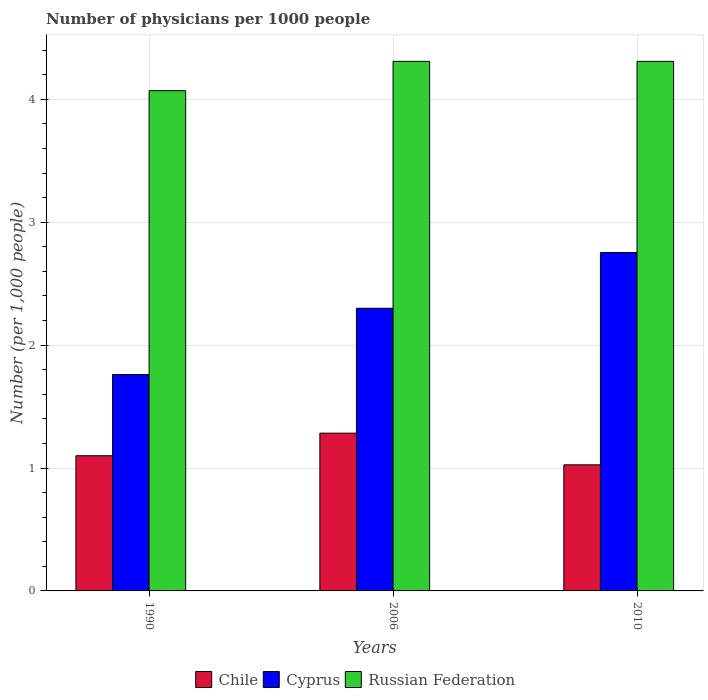How many groups of bars are there?
Your answer should be compact. 3. How many bars are there on the 2nd tick from the right?
Make the answer very short. 3. What is the number of physicians in Chile in 2006?
Make the answer very short. 1.28. Across all years, what is the maximum number of physicians in Chile?
Your response must be concise. 1.28. Across all years, what is the minimum number of physicians in Russian Federation?
Your answer should be compact. 4.07. In which year was the number of physicians in Cyprus maximum?
Provide a short and direct response. 2010. In which year was the number of physicians in Cyprus minimum?
Provide a succinct answer. 1990. What is the total number of physicians in Cyprus in the graph?
Ensure brevity in your answer.  6.81. What is the difference between the number of physicians in Chile in 2006 and that in 2010?
Offer a terse response. 0.26. What is the difference between the number of physicians in Chile in 2010 and the number of physicians in Cyprus in 2006?
Keep it short and to the point. -1.27. What is the average number of physicians in Russian Federation per year?
Provide a succinct answer. 4.23. In the year 2010, what is the difference between the number of physicians in Russian Federation and number of physicians in Cyprus?
Provide a short and direct response. 1.56. What is the ratio of the number of physicians in Cyprus in 1990 to that in 2006?
Keep it short and to the point. 0.77. Is the number of physicians in Chile in 1990 less than that in 2006?
Your response must be concise. Yes. What is the difference between the highest and the second highest number of physicians in Russian Federation?
Your answer should be very brief. 9.999999999976694e-5. What is the difference between the highest and the lowest number of physicians in Chile?
Provide a succinct answer. 0.26. What does the 2nd bar from the right in 2006 represents?
Provide a succinct answer. Cyprus. What is the difference between two consecutive major ticks on the Y-axis?
Your answer should be compact. 1. Does the graph contain grids?
Keep it short and to the point. Yes. What is the title of the graph?
Make the answer very short. Number of physicians per 1000 people. Does "United Kingdom" appear as one of the legend labels in the graph?
Give a very brief answer. No. What is the label or title of the X-axis?
Your answer should be compact. Years. What is the label or title of the Y-axis?
Keep it short and to the point. Number (per 1,0 people). What is the Number (per 1,000 people) of Chile in 1990?
Provide a short and direct response. 1.1. What is the Number (per 1,000 people) in Cyprus in 1990?
Your response must be concise. 1.76. What is the Number (per 1,000 people) in Russian Federation in 1990?
Make the answer very short. 4.07. What is the Number (per 1,000 people) of Chile in 2006?
Provide a succinct answer. 1.28. What is the Number (per 1,000 people) in Cyprus in 2006?
Your response must be concise. 2.3. What is the Number (per 1,000 people) in Russian Federation in 2006?
Your answer should be compact. 4.31. What is the Number (per 1,000 people) of Chile in 2010?
Offer a very short reply. 1.03. What is the Number (per 1,000 people) of Cyprus in 2010?
Make the answer very short. 2.75. What is the Number (per 1,000 people) of Russian Federation in 2010?
Provide a short and direct response. 4.31. Across all years, what is the maximum Number (per 1,000 people) of Chile?
Your answer should be very brief. 1.28. Across all years, what is the maximum Number (per 1,000 people) in Cyprus?
Your answer should be very brief. 2.75. Across all years, what is the maximum Number (per 1,000 people) of Russian Federation?
Provide a short and direct response. 4.31. Across all years, what is the minimum Number (per 1,000 people) in Cyprus?
Keep it short and to the point. 1.76. Across all years, what is the minimum Number (per 1,000 people) in Russian Federation?
Keep it short and to the point. 4.07. What is the total Number (per 1,000 people) of Chile in the graph?
Offer a terse response. 3.41. What is the total Number (per 1,000 people) in Cyprus in the graph?
Provide a succinct answer. 6.81. What is the total Number (per 1,000 people) of Russian Federation in the graph?
Your answer should be compact. 12.69. What is the difference between the Number (per 1,000 people) of Chile in 1990 and that in 2006?
Your answer should be very brief. -0.18. What is the difference between the Number (per 1,000 people) of Cyprus in 1990 and that in 2006?
Offer a terse response. -0.54. What is the difference between the Number (per 1,000 people) in Russian Federation in 1990 and that in 2006?
Keep it short and to the point. -0.24. What is the difference between the Number (per 1,000 people) of Chile in 1990 and that in 2010?
Offer a very short reply. 0.07. What is the difference between the Number (per 1,000 people) in Cyprus in 1990 and that in 2010?
Your answer should be very brief. -0.99. What is the difference between the Number (per 1,000 people) of Russian Federation in 1990 and that in 2010?
Provide a short and direct response. -0.24. What is the difference between the Number (per 1,000 people) of Chile in 2006 and that in 2010?
Keep it short and to the point. 0.26. What is the difference between the Number (per 1,000 people) of Cyprus in 2006 and that in 2010?
Offer a terse response. -0.45. What is the difference between the Number (per 1,000 people) in Chile in 1990 and the Number (per 1,000 people) in Cyprus in 2006?
Provide a short and direct response. -1.2. What is the difference between the Number (per 1,000 people) of Chile in 1990 and the Number (per 1,000 people) of Russian Federation in 2006?
Provide a succinct answer. -3.21. What is the difference between the Number (per 1,000 people) of Cyprus in 1990 and the Number (per 1,000 people) of Russian Federation in 2006?
Your answer should be compact. -2.55. What is the difference between the Number (per 1,000 people) of Chile in 1990 and the Number (per 1,000 people) of Cyprus in 2010?
Keep it short and to the point. -1.65. What is the difference between the Number (per 1,000 people) of Chile in 1990 and the Number (per 1,000 people) of Russian Federation in 2010?
Provide a succinct answer. -3.21. What is the difference between the Number (per 1,000 people) in Cyprus in 1990 and the Number (per 1,000 people) in Russian Federation in 2010?
Provide a short and direct response. -2.55. What is the difference between the Number (per 1,000 people) of Chile in 2006 and the Number (per 1,000 people) of Cyprus in 2010?
Ensure brevity in your answer.  -1.47. What is the difference between the Number (per 1,000 people) of Chile in 2006 and the Number (per 1,000 people) of Russian Federation in 2010?
Your response must be concise. -3.03. What is the difference between the Number (per 1,000 people) in Cyprus in 2006 and the Number (per 1,000 people) in Russian Federation in 2010?
Provide a short and direct response. -2.01. What is the average Number (per 1,000 people) in Chile per year?
Give a very brief answer. 1.14. What is the average Number (per 1,000 people) of Cyprus per year?
Keep it short and to the point. 2.27. What is the average Number (per 1,000 people) in Russian Federation per year?
Make the answer very short. 4.23. In the year 1990, what is the difference between the Number (per 1,000 people) in Chile and Number (per 1,000 people) in Cyprus?
Give a very brief answer. -0.66. In the year 1990, what is the difference between the Number (per 1,000 people) in Chile and Number (per 1,000 people) in Russian Federation?
Offer a very short reply. -2.97. In the year 1990, what is the difference between the Number (per 1,000 people) of Cyprus and Number (per 1,000 people) of Russian Federation?
Give a very brief answer. -2.31. In the year 2006, what is the difference between the Number (per 1,000 people) of Chile and Number (per 1,000 people) of Cyprus?
Provide a short and direct response. -1.02. In the year 2006, what is the difference between the Number (per 1,000 people) in Chile and Number (per 1,000 people) in Russian Federation?
Your answer should be very brief. -3.03. In the year 2006, what is the difference between the Number (per 1,000 people) of Cyprus and Number (per 1,000 people) of Russian Federation?
Give a very brief answer. -2.01. In the year 2010, what is the difference between the Number (per 1,000 people) of Chile and Number (per 1,000 people) of Cyprus?
Your answer should be very brief. -1.73. In the year 2010, what is the difference between the Number (per 1,000 people) of Chile and Number (per 1,000 people) of Russian Federation?
Provide a succinct answer. -3.28. In the year 2010, what is the difference between the Number (per 1,000 people) of Cyprus and Number (per 1,000 people) of Russian Federation?
Your answer should be very brief. -1.56. What is the ratio of the Number (per 1,000 people) in Chile in 1990 to that in 2006?
Provide a short and direct response. 0.86. What is the ratio of the Number (per 1,000 people) in Cyprus in 1990 to that in 2006?
Keep it short and to the point. 0.77. What is the ratio of the Number (per 1,000 people) of Russian Federation in 1990 to that in 2006?
Give a very brief answer. 0.94. What is the ratio of the Number (per 1,000 people) of Chile in 1990 to that in 2010?
Ensure brevity in your answer.  1.07. What is the ratio of the Number (per 1,000 people) in Cyprus in 1990 to that in 2010?
Your response must be concise. 0.64. What is the ratio of the Number (per 1,000 people) of Russian Federation in 1990 to that in 2010?
Keep it short and to the point. 0.94. What is the ratio of the Number (per 1,000 people) of Chile in 2006 to that in 2010?
Provide a succinct answer. 1.25. What is the ratio of the Number (per 1,000 people) of Cyprus in 2006 to that in 2010?
Offer a terse response. 0.84. What is the difference between the highest and the second highest Number (per 1,000 people) of Chile?
Your answer should be compact. 0.18. What is the difference between the highest and the second highest Number (per 1,000 people) in Cyprus?
Make the answer very short. 0.45. What is the difference between the highest and the second highest Number (per 1,000 people) in Russian Federation?
Offer a very short reply. 0. What is the difference between the highest and the lowest Number (per 1,000 people) in Chile?
Provide a short and direct response. 0.26. What is the difference between the highest and the lowest Number (per 1,000 people) in Cyprus?
Offer a very short reply. 0.99. What is the difference between the highest and the lowest Number (per 1,000 people) in Russian Federation?
Your answer should be compact. 0.24. 